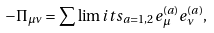Convert formula to latex. <formula><loc_0><loc_0><loc_500><loc_500>- \Pi _ { \mu \nu } = \sum \lim i t s _ { a = 1 , 2 } e _ { \mu } ^ { ( a ) } e _ { \nu } ^ { ( a ) } ,</formula> 